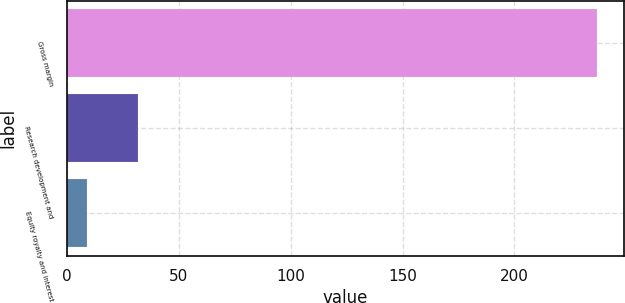<chart> <loc_0><loc_0><loc_500><loc_500><bar_chart><fcel>Gross margin<fcel>Research development and<fcel>Equity royalty and interest<nl><fcel>237<fcel>31.8<fcel>9<nl></chart> 